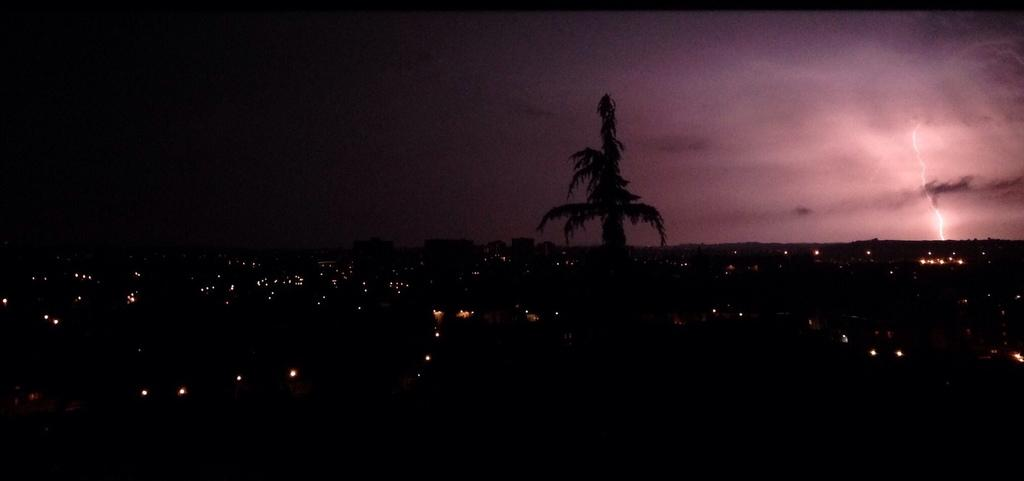Where was the picture taken? The picture was clicked outside. What can be seen in the foreground of the image? There are lights and other objects in the foreground of the image. What is visible in the background of the image? The sky and trees are visible in the background of the image. What weather condition is present in the image? There is lightning in the sky. What type of wall can be seen in the image? There is no wall present in the image. What direction is the power coming from in the image? There is no reference to power or its direction in the image. 